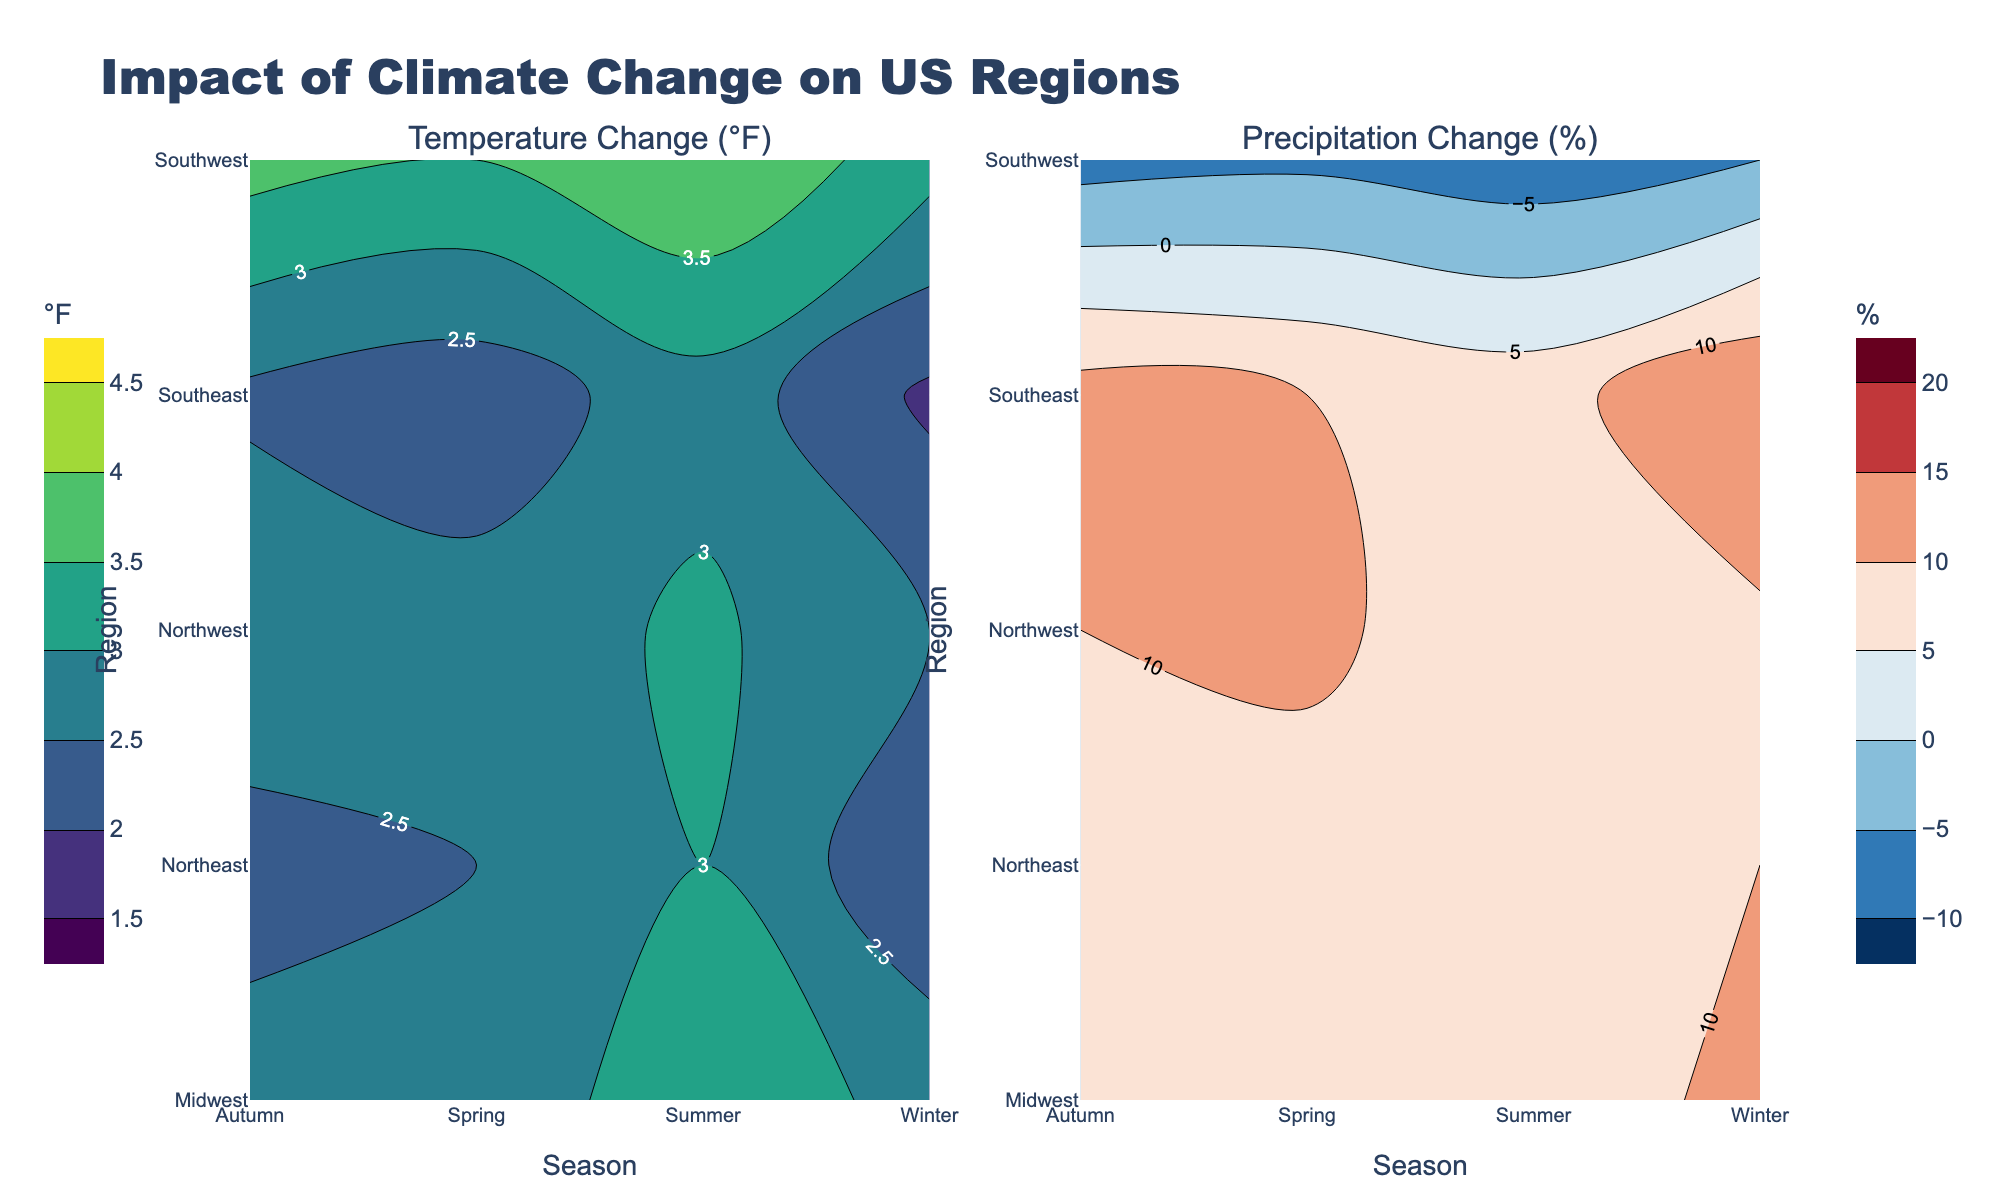What is the title of the left subplot? The left subplot is a contour plot that shows the temperature changes. The subplot titles are displayed above each subplot. The left one reads "Temperature Change (°F)."
Answer: Temperature Change (°F) What season shows the highest temperature change in the Southwest region? Review the contour plot on the left for temperature changes, identify the Southwest region, and check which season has the highest indicated temperature change. The colors are darker green as the temperature increases. Summer shows the highest temperature change in the Southwest.
Answer: Summer Compare the precipitation change in the Southeast region during Winter and Autumn. Which season has a higher change? Look at the contour plot on the right for precipitation changes, identify the Southeast region, and compare the color labels for Winter and Autumn. The colors used in the Seasonal legend help determine the percentage change. Winter has a higher precipitation change percentage compared to Autumn.
Answer: Winter What is the common temperature change range in the Midwest region for all seasons? Observe the Midwest region on the temperature contour plot. Look at the contour levels for Winter, Spring, Summer, and Autumn seasons. These changes vary between slightly under 3°F to 3.4°F. Common range is from about 2.6°F to 3.4°F.
Answer: 2.6°F to 3.4°F Which region experiences a decrease in precipitation during any season? Review the precipitation contour plot for any negative values (red colors). The Southwest region shows negative precipitation changes in seasons with red contour lines.
Answer: Southwest What is the average temperature change in the Northwest region across all seasons? Calculate the average by summing the temperature changes in the Northwest for Winter (2.5°F), Spring (2.7°F), Summer (3.1°F), and Autumn (2.9°F), and then dividing by 4. Sum is (2.5 + 2.7 + 3.1 + 2.9) = 11.2, so average is 11.2/4 = 2.8°F.
Answer: 2.8°F Which season has the largest range of temperature changes across all regions? Compare the ranges of temperature changes for Winter, Spring, Summer, and Autumn across all regions by viewing the contour labels. Summer has the largest range with values from around 2.8°F to 4.0°F.
Answer: Summer Which region has the smallest change in temperature in Winter? Look at the temperature changes labeled for Winter across regions. The Southeast has the smallest change at 1.9°F in the contour plot.
Answer: Southeast 